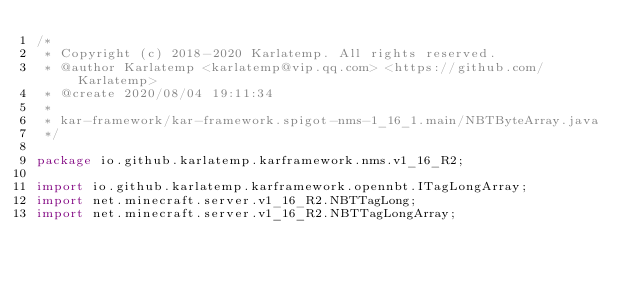Convert code to text. <code><loc_0><loc_0><loc_500><loc_500><_Java_>/*
 * Copyright (c) 2018-2020 Karlatemp. All rights reserved.
 * @author Karlatemp <karlatemp@vip.qq.com> <https://github.com/Karlatemp>
 * @create 2020/08/04 19:11:34
 *
 * kar-framework/kar-framework.spigot-nms-1_16_1.main/NBTByteArray.java
 */

package io.github.karlatemp.karframework.nms.v1_16_R2;

import io.github.karlatemp.karframework.opennbt.ITagLongArray;
import net.minecraft.server.v1_16_R2.NBTTagLong;
import net.minecraft.server.v1_16_R2.NBTTagLongArray;</code> 